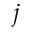Convert formula to latex. <formula><loc_0><loc_0><loc_500><loc_500>j</formula> 